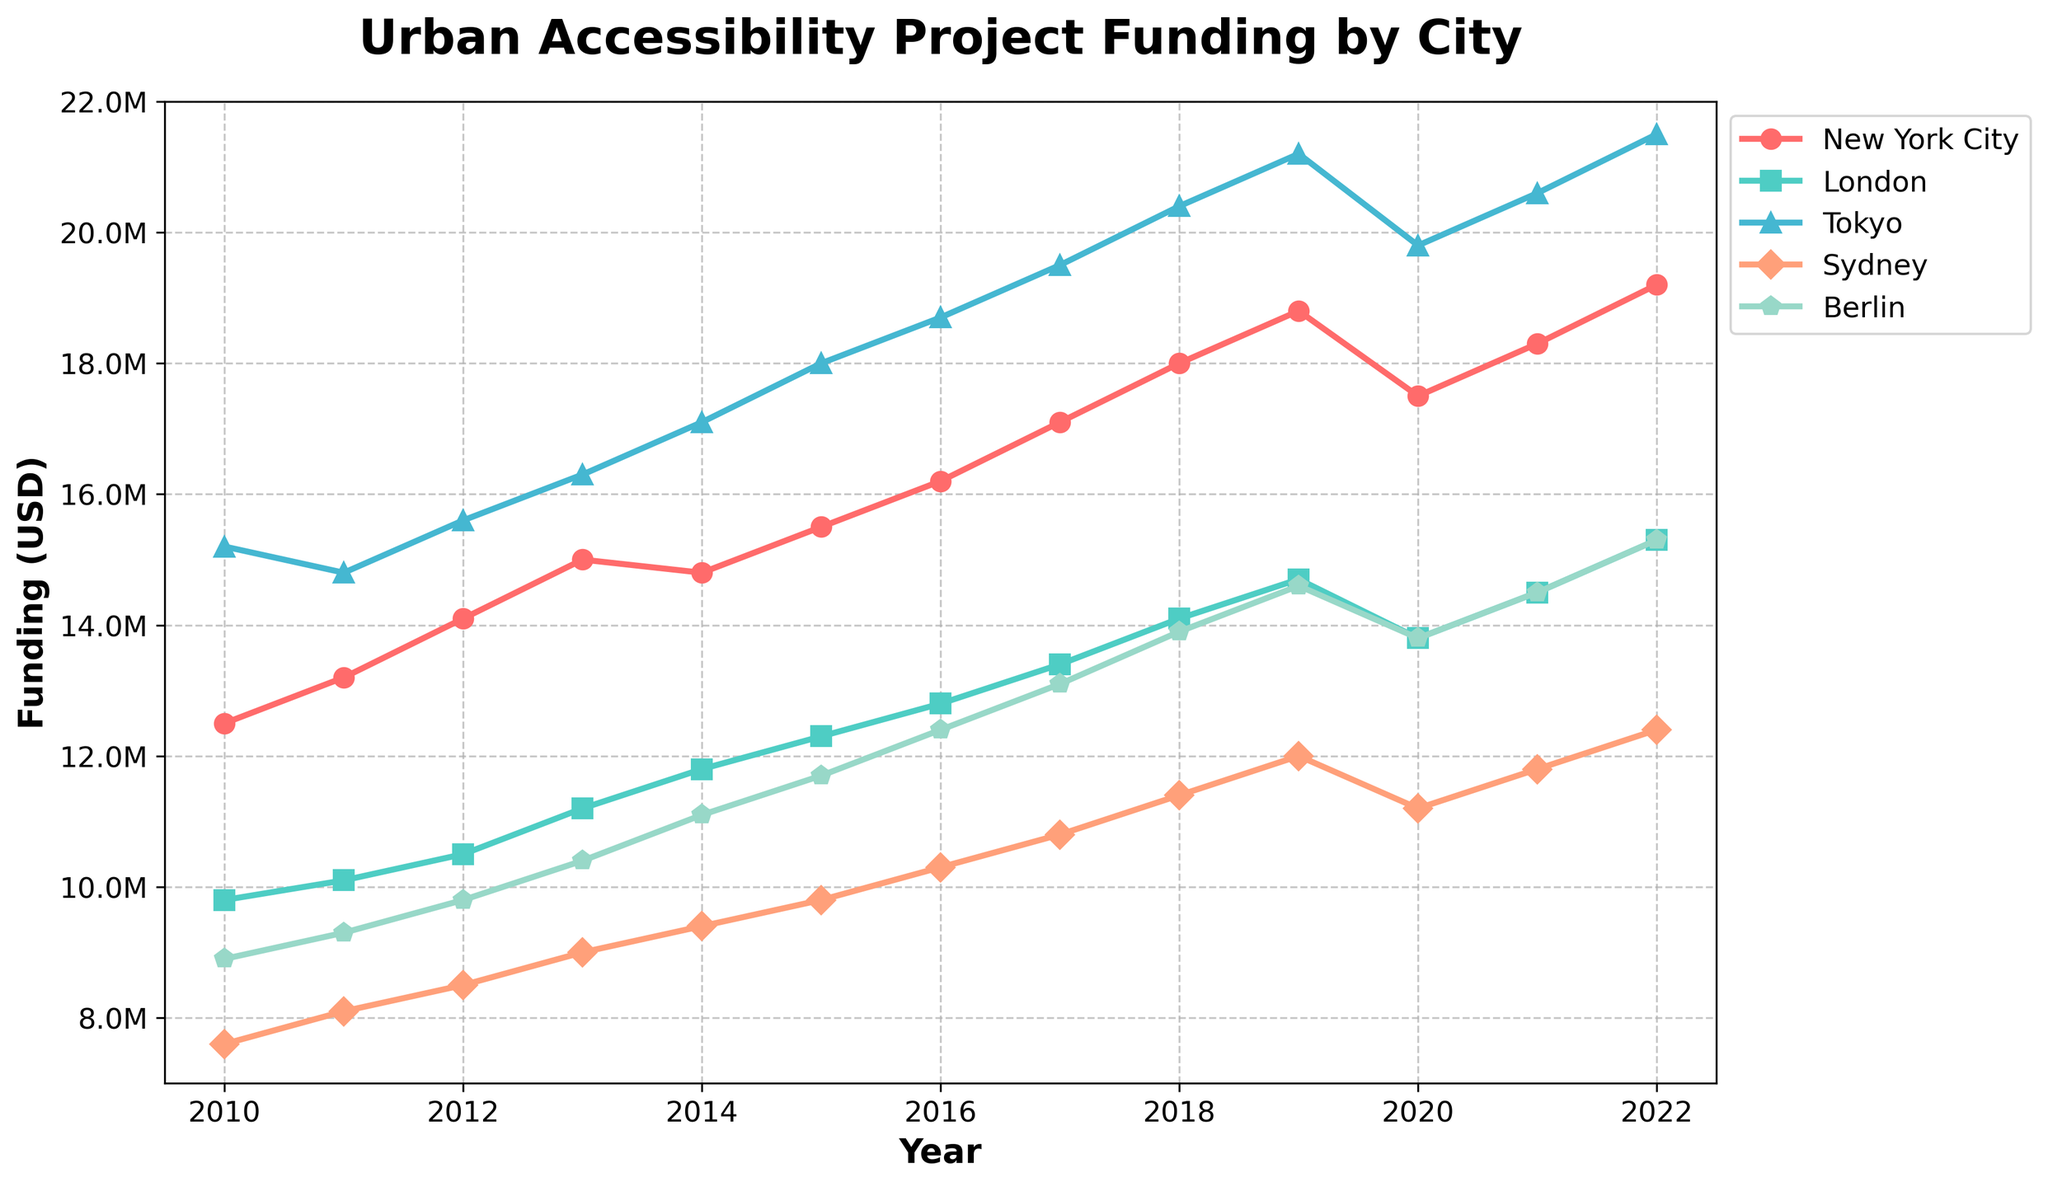What is the general trend in funding for urban accessibility projects in New York City over the years? The line representing New York City's funding shows a consistent upward trend from 2010 to 2022, peaking in 2022.
Answer: Increasing In which year did Tokyo receive the highest funding for urban accessibility projects? By looking at the line associated with Tokyo, the highest point is in the year 2022.
Answer: 2022 Compare the funding trends of London and Berlin in 2020. Did London receive more funding than Berlin? In 2020, the point for London is higher than the point for Berlin.
Answer: Yes Which city saw a decrease in funding in 2020 compared to 2019? By examining the lines, New York City, London, and Tokyo all show a drop in funding in 2020 compared to 2019.
Answer: New York City, London, Tokyo From 2015 to 2022, which city had the most consistent year-over-year growth? Tokyo's line shows a consistent and smooth increase each year from 2015 to 2022 compared to the other cities.
Answer: Tokyo Among the cities, which city had the lowest funding in 2011? The point for 2011 on Sydney's line is the lowest among all the cities.
Answer: Sydney Calculate the total funding for urban accessibility projects in Berlin from 2010 to 2022. By summing the values for Berlin from 2010 to 2022: 8900000 + 9300000 + 9800000 + 10400000 + 11100000 + 11700000 + 12400000 + 13100000 + 13900000 + 14600000 + 13800000 + 14500000 + 15300000 = 164200000
Answer: 164200000 Which city had a higher average funding over the period of 2010 to 2022, New York City or London? Calculate the average by summing up the values and dividing by the number of years (13):
New York City: (12500000 + 13200000 + 14100000 + 15000000 + 14800000 + 15500000 + 16200000 + 17100000 + 18000000 + 18800000 + 17500000 + 18300000 + 19200000) / 13 = 16123077
London: (9800000 + 10100000 + 10500000 + 11200000 + 11800000 + 12300000 + 12800000 + 13400000 + 14100000 + 14700000 + 13800000 + 14500000 + 15300000) / 13 = 12261538. London has a lower average than New York City.
Answer: New York City Identify any years where multiple cities had the same funding amount and name those cities and the funding amount for that year. In 2020, both London and Berlin had funding of $13800000.
Answer: London, Berlin, $13800000 Which city showed the most volatility in their funding pattern from 2010 to 2022? By visually inspecting the variability and changes in the slopes of the lines, New York City's line shows some fluctuations but relatively smoother than others. Berlin and Sydney have relatively more fluctuations in their funding amounts year over year.
Answer: Sydney 